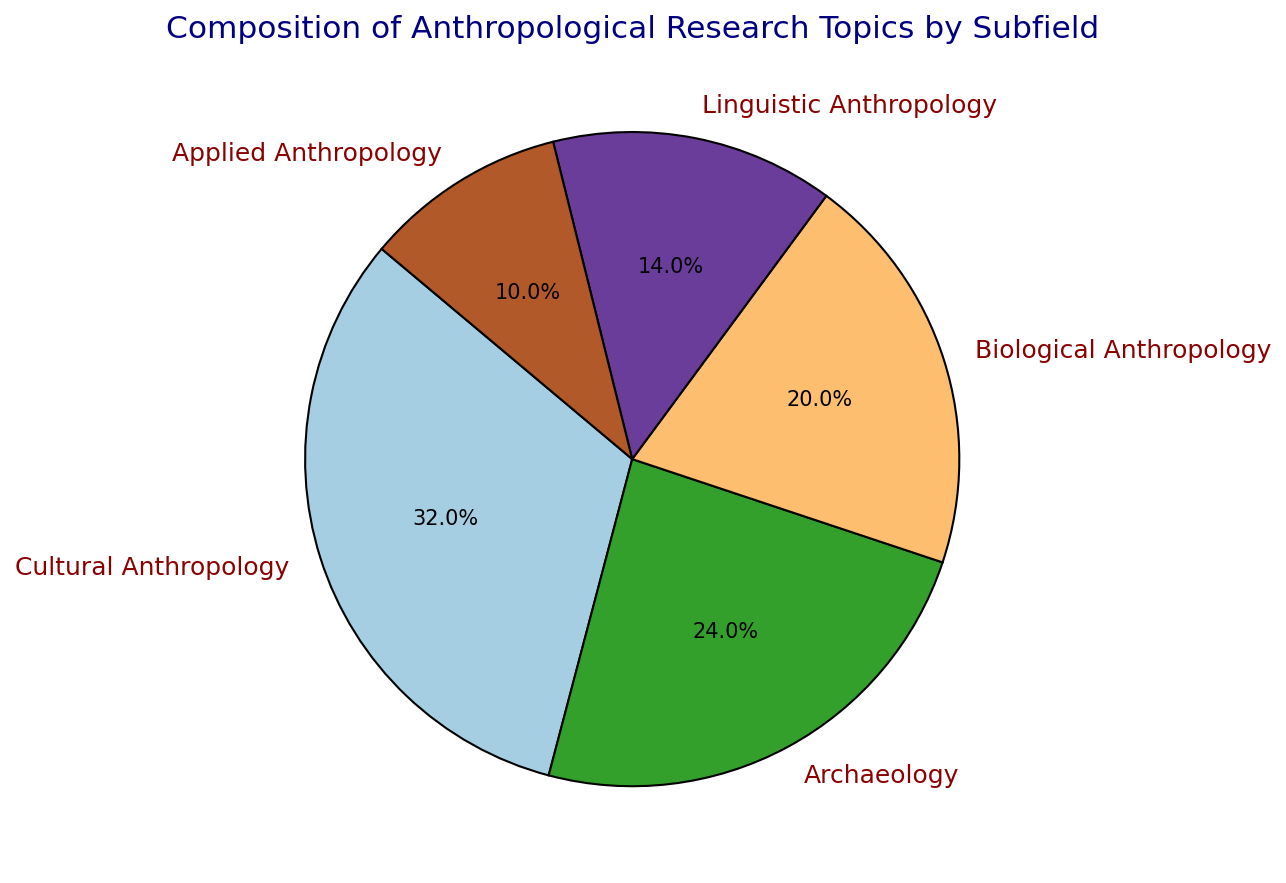What percentage of anthropological research topics are divided into Cultural Anthropology and Linguistic Anthropology combined? To find out the combined percentage, add the percentage of Cultural Anthropology (32%) and Linguistic Anthropology (14%). The combined percentage is 32% + 14% = 46%.
Answer: 46% Which subfield has the smallest proportion of research topics? By comparing all the percentage values in the pie chart, Linguistic Anthropology has the smallest proportion with 14%.
Answer: Linguistic Anthropology How much larger is the percentage of Cultural Anthropology compared to Applied Anthropology? The percentage for Cultural Anthropology is 32% and for Applied Anthropology is 10%. The difference is 32% - 10% = 22%.
Answer: 22% What is the combined percentage of Archaeology and Biological Anthropology? Add the percentages of Archaeology (24%) and Biological Anthropology (20%). The combined percentage is 24% + 20% = 44%.
Answer: 44% Which two subfields together make up over half of the anthropological research topics? Checking the combined percentages: Cultural Anthropology (32%) + Archaeology (24%) = 56%, which is over half.
Answer: Cultural Anthropology and Archaeology Which subfield contributes almost one-third of the total research topics? Cultural Anthropology accounts for 32%, which is the closest subfield to one-third of 100%.
Answer: Cultural Anthropology What color represents the Biological Anthropology slice in the pie chart? Observe the color scheme in the pie chart and identify the segment labeled "Biological Anthropology."
Answer: (Specific color description needed) How does the proportion of Applied Anthropology compare to the proportion of Archaeology? Applied Anthropology has 10% while Archaeology has 24%. Archaeology’s proportion is more than double that of Applied Anthropology.
Answer: Archaeology is more than double Applied Anthropology Which two subfields have a combined percentage equal to the percentage of Cultural Anthropology? Adding the percentages of Biological Anthropology (20%) and Linguistic Anthropology (14%) results in 20% + 14% = 34%, which is closest to Cultural Anthropology's 32%. But this doesn't exactly match. Upon closer inspection, no pairs exactly add up to 32%. Therefore, a possible closest match is not precise.
Answer: No exact match If the total number of research papers is 100, how many research papers belong to the Archaeology subfield? Given that Archaeology is 24% of the total research, multiply 24% by the total number of papers (100). So, 24% of 100 is 24 papers.
Answer: 24 